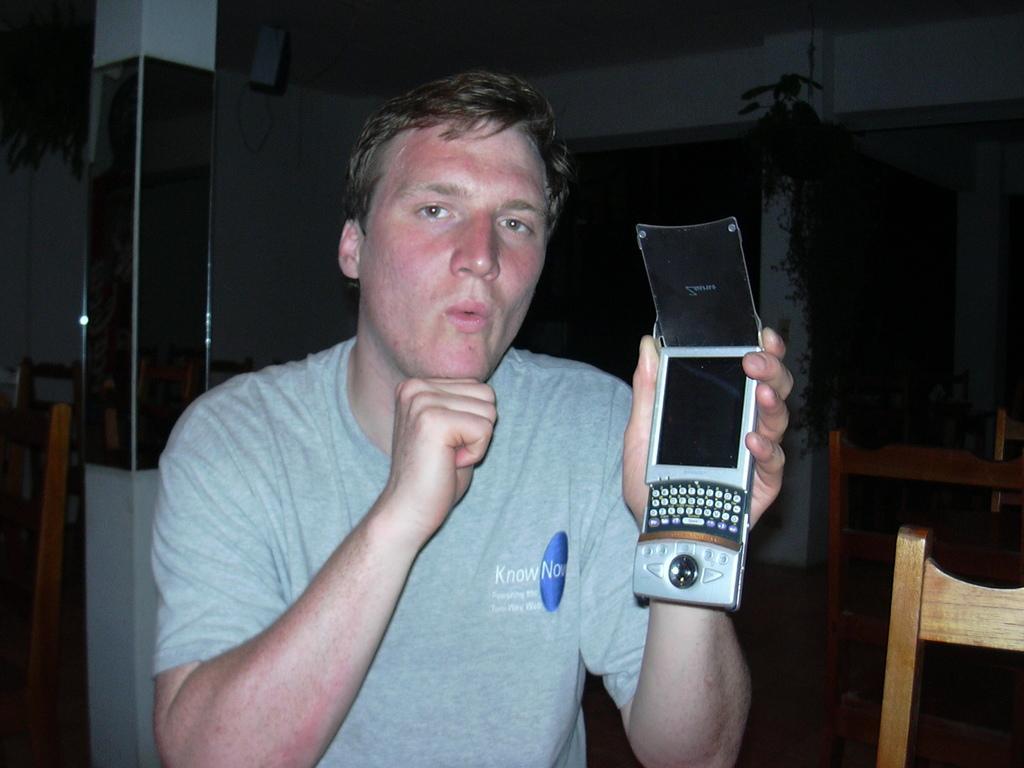Describe this image in one or two sentences. In this image we can see a person is sitting on the chair and holding a mobile phone in his hands. In the background we can see chairs and pillar. 